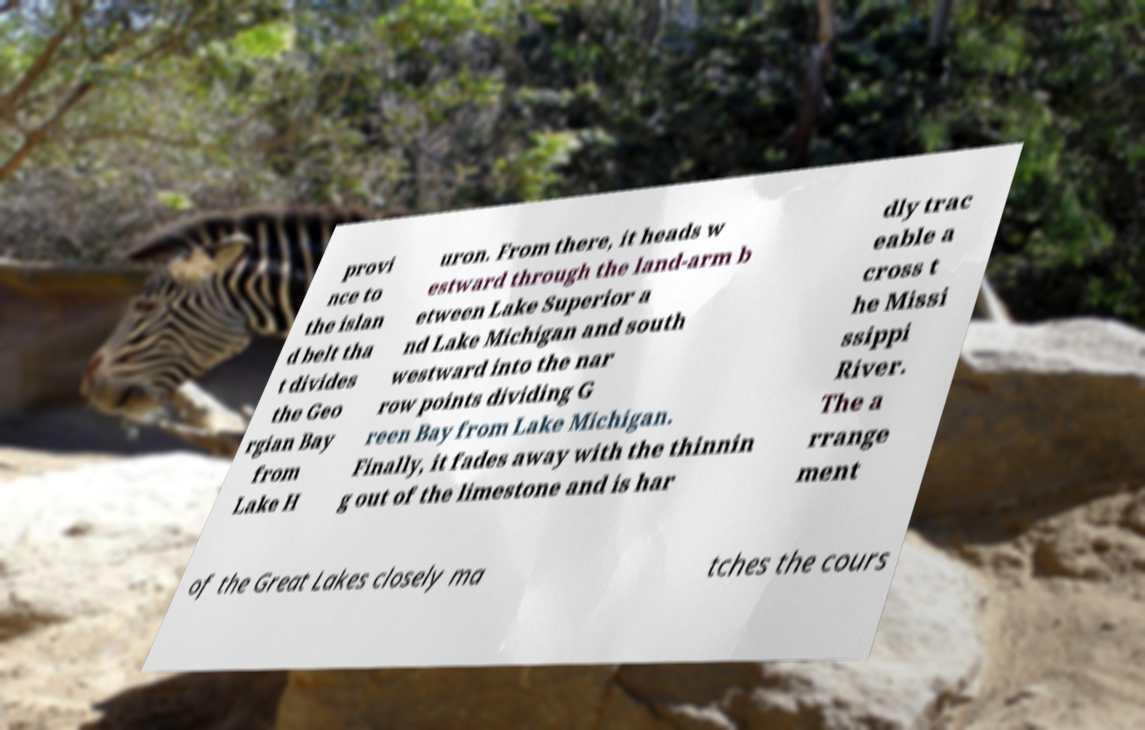Can you read and provide the text displayed in the image?This photo seems to have some interesting text. Can you extract and type it out for me? provi nce to the islan d belt tha t divides the Geo rgian Bay from Lake H uron. From there, it heads w estward through the land-arm b etween Lake Superior a nd Lake Michigan and south westward into the nar row points dividing G reen Bay from Lake Michigan. Finally, it fades away with the thinnin g out of the limestone and is har dly trac eable a cross t he Missi ssippi River. The a rrange ment of the Great Lakes closely ma tches the cours 